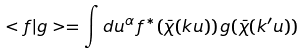Convert formula to latex. <formula><loc_0><loc_0><loc_500><loc_500>< f | g > = \int d u ^ { \alpha } \, f ^ { * } ( \bar { \chi } ( k u ) ) \, g ( \bar { \chi } ( k ^ { \prime } u ) )</formula> 